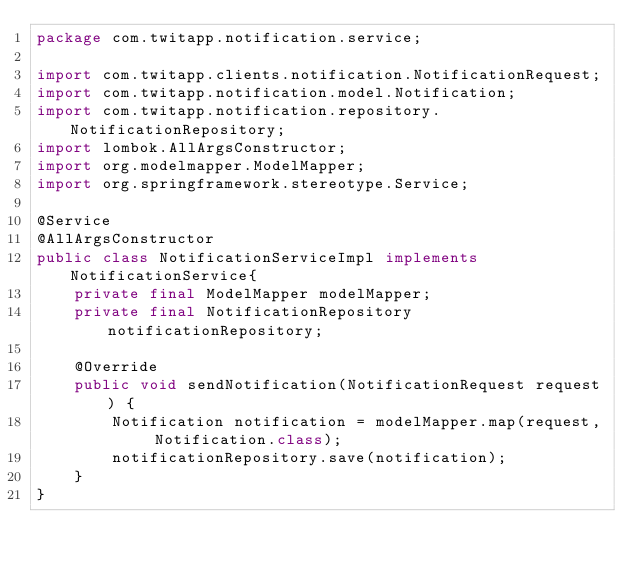Convert code to text. <code><loc_0><loc_0><loc_500><loc_500><_Java_>package com.twitapp.notification.service;

import com.twitapp.clients.notification.NotificationRequest;
import com.twitapp.notification.model.Notification;
import com.twitapp.notification.repository.NotificationRepository;
import lombok.AllArgsConstructor;
import org.modelmapper.ModelMapper;
import org.springframework.stereotype.Service;

@Service
@AllArgsConstructor
public class NotificationServiceImpl implements NotificationService{
    private final ModelMapper modelMapper;
    private final NotificationRepository notificationRepository;

    @Override
    public void sendNotification(NotificationRequest request) {
        Notification notification = modelMapper.map(request, Notification.class);
        notificationRepository.save(notification);
    }
}
</code> 